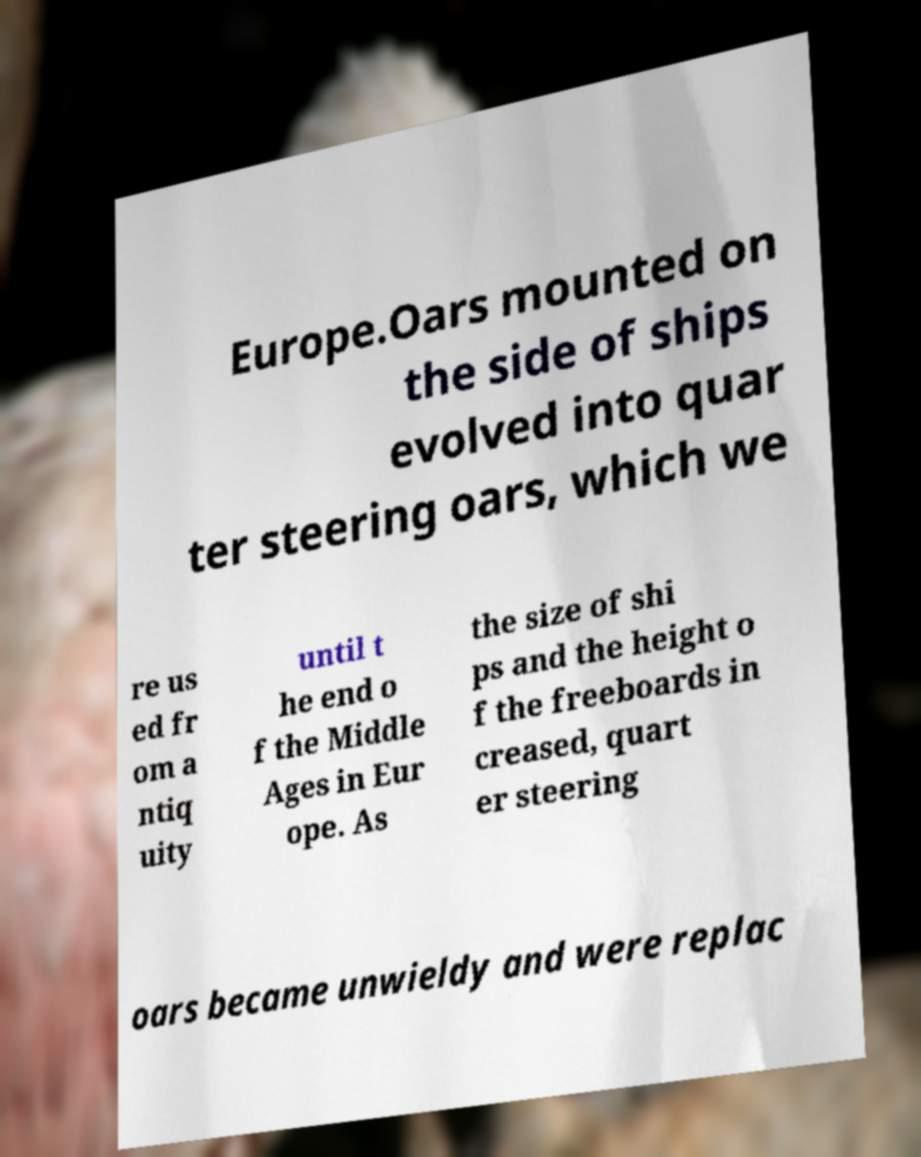There's text embedded in this image that I need extracted. Can you transcribe it verbatim? Europe.Oars mounted on the side of ships evolved into quar ter steering oars, which we re us ed fr om a ntiq uity until t he end o f the Middle Ages in Eur ope. As the size of shi ps and the height o f the freeboards in creased, quart er steering oars became unwieldy and were replac 